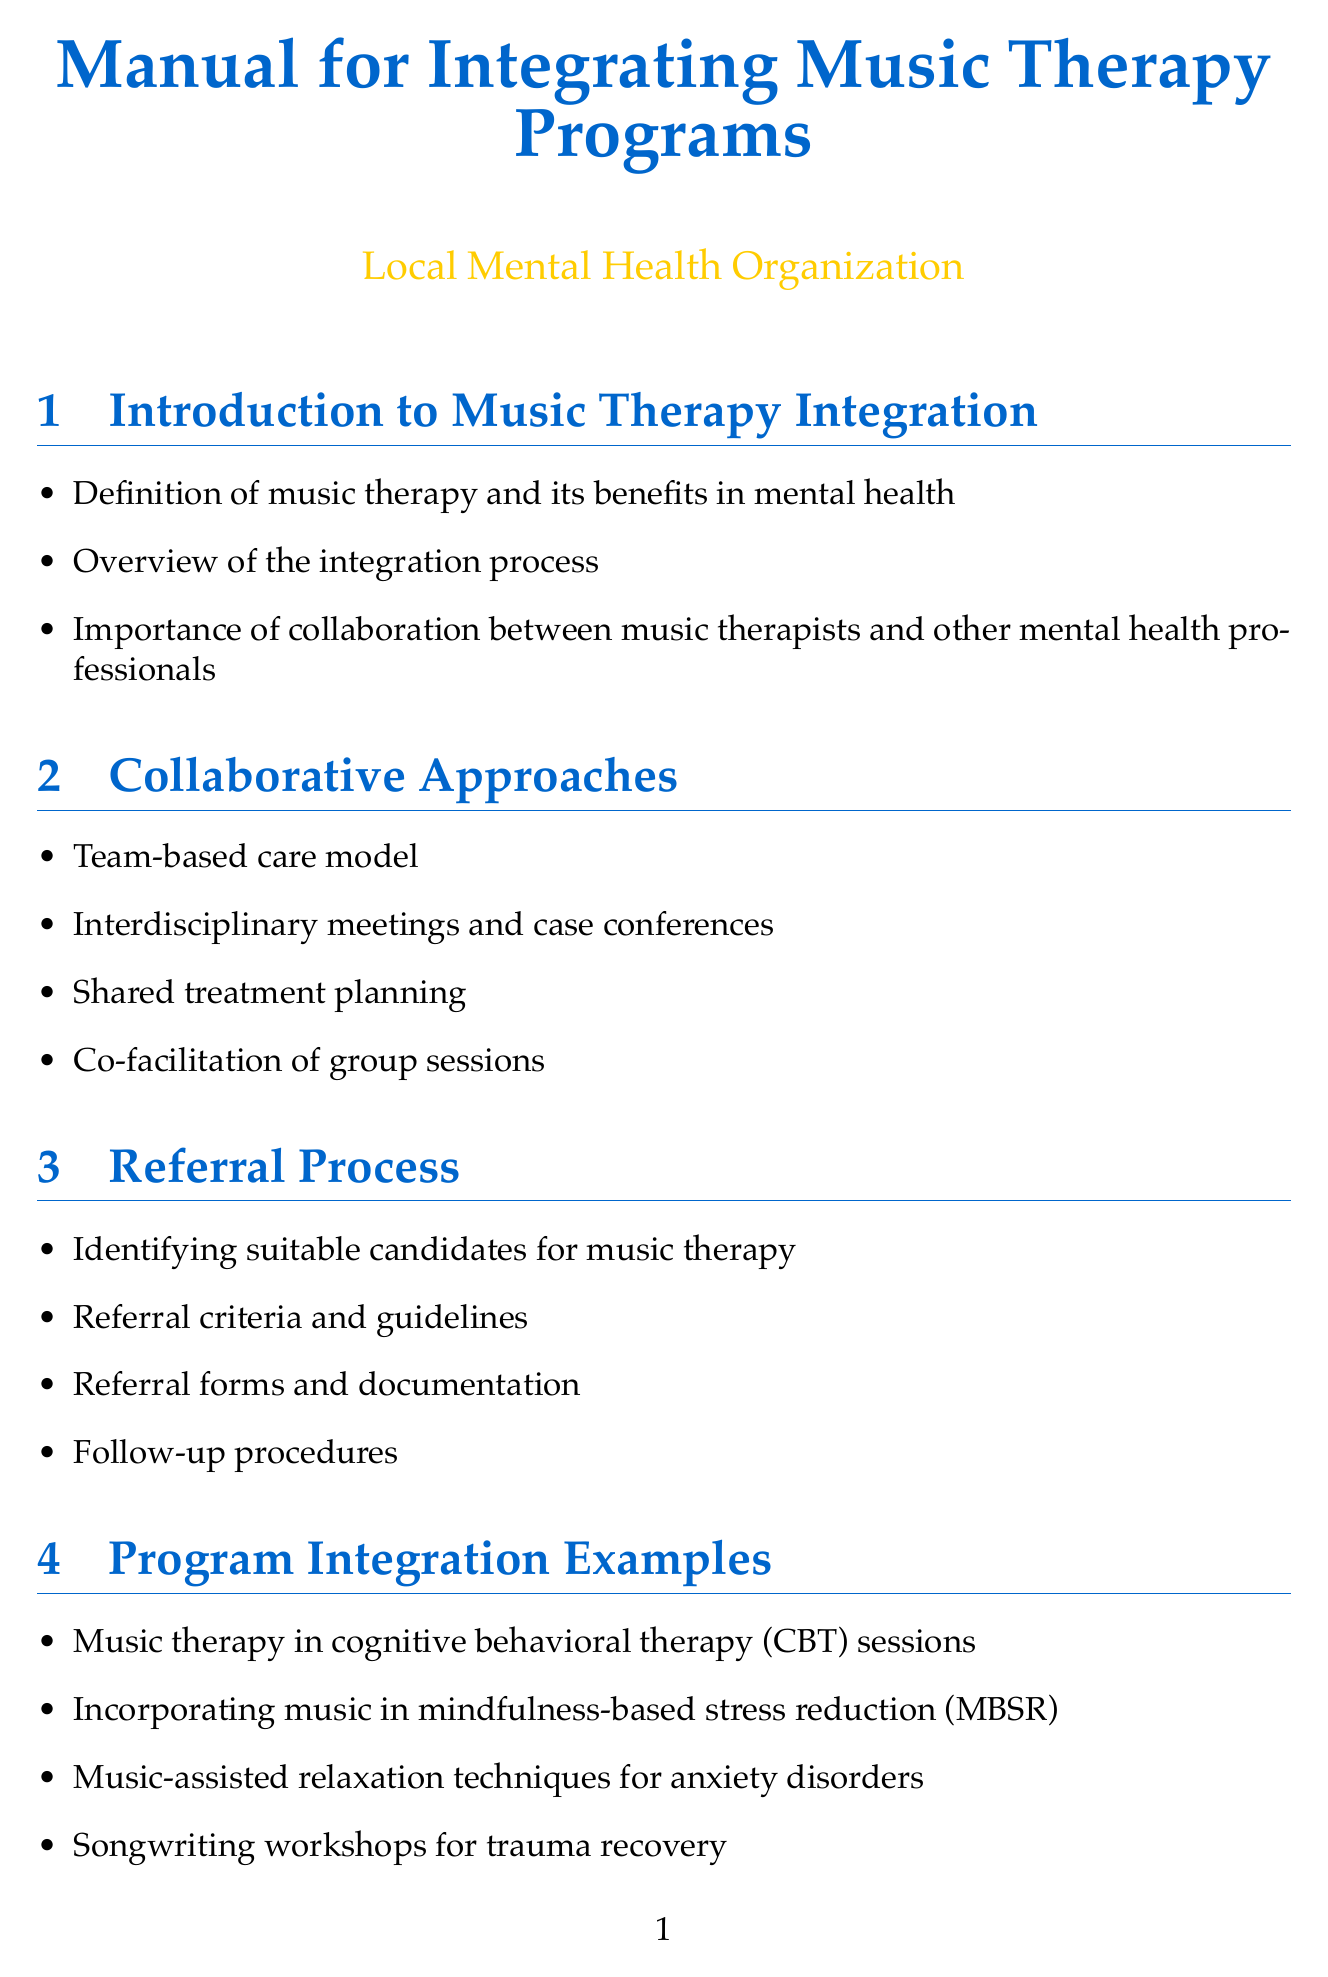What is music therapy? Music therapy is defined as a therapeutic approach utilizing music to support mental health, as mentioned in the introduction section.
Answer: A therapeutic approach utilizing music What are the methods of collaborative approaches listed? The document outlines team-based care, interdisciplinary meetings, shared treatment planning, and co-facilitation as collaborative approaches.
Answer: Team-based care model, interdisciplinary meetings, shared treatment planning, co-facilitation What is the first step in the referral process? The first step in the referral process is identifying suitable candidates for music therapy.
Answer: Identifying suitable candidates for music therapy List one example of program integration. The document provides several examples of integrating music therapy; one is music therapy in cognitive behavioral therapy (CBT) sessions.
Answer: Music therapy in cognitive behavioral therapy (CBT) sessions What is the purpose of communication protocols? The communication protocols aim to establish clear communication among team members and maintain confidentiality.
Answer: Establish clear lines of communication Name a type of training mentioned in the manual. The manual mentions cross-training sessions for mental health professionals as one type of training.
Answer: Cross-training sessions for mental health professionals How is data analyzed for program improvement? The manual states that data is analyzed by tracking progress and treatment outcomes.
Answer: Tracking progress and treatment outcomes What are the appendices intended for? The appendices provide sample referral forms, collaborative treatment plan templates, and recommended music therapy resources.
Answer: Sample referral forms, collaborative treatment plan templates, recommended music therapy resources 